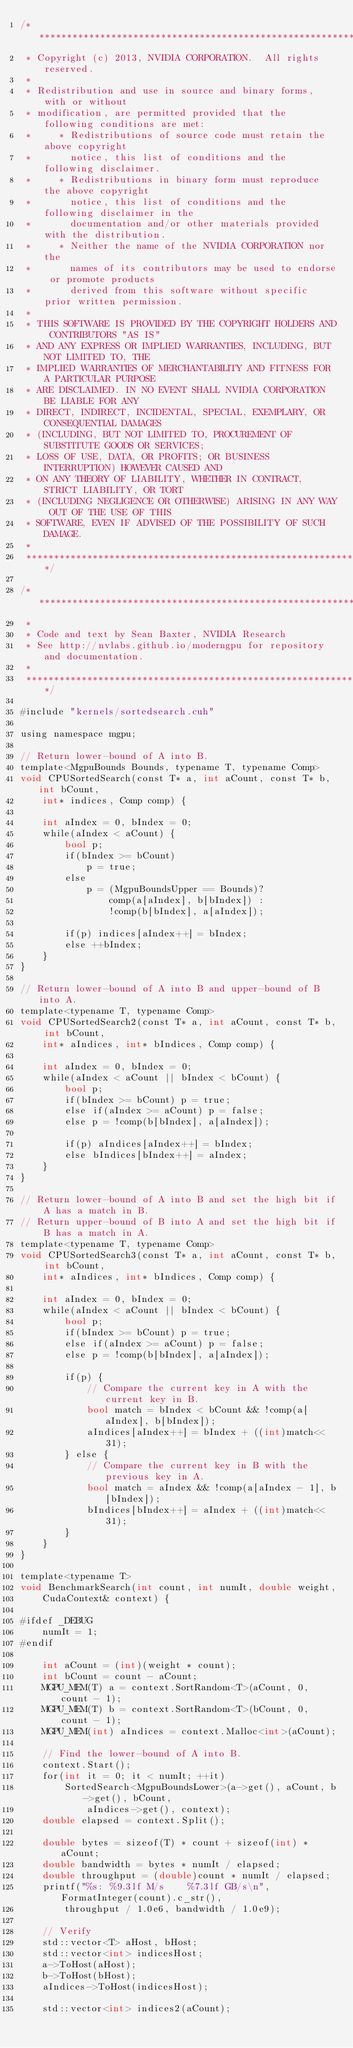<code> <loc_0><loc_0><loc_500><loc_500><_Cuda_>/******************************************************************************
 * Copyright (c) 2013, NVIDIA CORPORATION.  All rights reserved.
 * 
 * Redistribution and use in source and binary forms, with or without
 * modification, are permitted provided that the following conditions are met:
 *     * Redistributions of source code must retain the above copyright
 *       notice, this list of conditions and the following disclaimer.
 *     * Redistributions in binary form must reproduce the above copyright
 *       notice, this list of conditions and the following disclaimer in the
 *       documentation and/or other materials provided with the distribution.
 *     * Neither the name of the NVIDIA CORPORATION nor the
 *       names of its contributors may be used to endorse or promote products
 *       derived from this software without specific prior written permission.
 * 
 * THIS SOFTWARE IS PROVIDED BY THE COPYRIGHT HOLDERS AND CONTRIBUTORS "AS IS" 
 * AND ANY EXPRESS OR IMPLIED WARRANTIES, INCLUDING, BUT NOT LIMITED TO, THE
 * IMPLIED WARRANTIES OF MERCHANTABILITY AND FITNESS FOR A PARTICULAR PURPOSE 
 * ARE DISCLAIMED. IN NO EVENT SHALL NVIDIA CORPORATION BE LIABLE FOR ANY
 * DIRECT, INDIRECT, INCIDENTAL, SPECIAL, EXEMPLARY, OR CONSEQUENTIAL DAMAGES
 * (INCLUDING, BUT NOT LIMITED TO, PROCUREMENT OF SUBSTITUTE GOODS OR SERVICES;
 * LOSS OF USE, DATA, OR PROFITS; OR BUSINESS INTERRUPTION) HOWEVER CAUSED AND
 * ON ANY THEORY OF LIABILITY, WHETHER IN CONTRACT, STRICT LIABILITY, OR TORT
 * (INCLUDING NEGLIGENCE OR OTHERWISE) ARISING IN ANY WAY OUT OF THE USE OF THIS
 * SOFTWARE, EVEN IF ADVISED OF THE POSSIBILITY OF SUCH DAMAGE.
 *
 ******************************************************************************/

/******************************************************************************
 *
 * Code and text by Sean Baxter, NVIDIA Research
 * See http://nvlabs.github.io/moderngpu for repository and documentation.
 *
 ******************************************************************************/

#include "kernels/sortedsearch.cuh"

using namespace mgpu;

// Return lower-bound of A into B.
template<MgpuBounds Bounds, typename T, typename Comp>
void CPUSortedSearch(const T* a, int aCount, const T* b, int bCount, 
	int* indices, Comp comp) {
		
	int aIndex = 0, bIndex = 0;
	while(aIndex < aCount) {
		bool p;
		if(bIndex >= bCount)
			p = true;
		else 
			p = (MgpuBoundsUpper == Bounds)?
				comp(a[aIndex], b[bIndex]) :
				!comp(b[bIndex], a[aIndex]);

		if(p) indices[aIndex++] = bIndex;
		else ++bIndex;
	}
}

// Return lower-bound of A into B and upper-bound of B into A.
template<typename T, typename Comp>
void CPUSortedSearch2(const T* a, int aCount, const T* b, int bCount, 
	int* aIndices, int* bIndices, Comp comp) {

	int aIndex = 0, bIndex = 0;
	while(aIndex < aCount || bIndex < bCount) {
		bool p;
		if(bIndex >= bCount) p = true;
		else if(aIndex >= aCount) p = false;
		else p = !comp(b[bIndex], a[aIndex]);

		if(p) aIndices[aIndex++] = bIndex;
		else bIndices[bIndex++] = aIndex;
	}
}

// Return lower-bound of A into B and set the high bit if A has a match in B.
// Return upper-bound of B into A and set the high bit if B has a match in A.
template<typename T, typename Comp>
void CPUSortedSearch3(const T* a, int aCount, const T* b, int bCount,
	int* aIndices, int* bIndices, Comp comp) {

	int aIndex = 0, bIndex = 0;
	while(aIndex < aCount || bIndex < bCount) {
		bool p;
		if(bIndex >= bCount) p = true;
		else if(aIndex >= aCount) p = false;
		else p = !comp(b[bIndex], a[aIndex]);

		if(p) {
			// Compare the current key in A with the current key in B.
			bool match = bIndex < bCount && !comp(a[aIndex], b[bIndex]);
			aIndices[aIndex++] = bIndex + ((int)match<< 31);
		} else {
			// Compare the current key in B with the previous key in A.
			bool match = aIndex && !comp(a[aIndex - 1], b[bIndex]);
			bIndices[bIndex++] = aIndex + ((int)match<< 31);
		}
	}
}

template<typename T>
void BenchmarkSearch(int count, int numIt, double weight, 
	CudaContext& context) {

#ifdef _DEBUG
	numIt = 1;
#endif

	int aCount = (int)(weight * count);
	int bCount = count - aCount;
	MGPU_MEM(T) a = context.SortRandom<T>(aCount, 0, count - 1);
	MGPU_MEM(T) b = context.SortRandom<T>(bCount, 0, count - 1);
	MGPU_MEM(int) aIndices = context.Malloc<int>(aCount);

	// Find the lower-bound of A into B.
	context.Start();
	for(int it = 0; it < numIt; ++it) 
		SortedSearch<MgpuBoundsLower>(a->get(), aCount, b->get(), bCount,
			aIndices->get(), context);
	double elapsed = context.Split();

	double bytes = sizeof(T) * count + sizeof(int) * aCount;
	double bandwidth = bytes * numIt / elapsed;
	double throughput = (double)count * numIt / elapsed;
	printf("%s: %9.3lf M/s    %7.3lf GB/s\n", FormatInteger(count).c_str(),
		throughput / 1.0e6, bandwidth / 1.0e9);

	// Verify
	std::vector<T> aHost, bHost;
	std::vector<int> indicesHost;
	a->ToHost(aHost);
	b->ToHost(bHost);
	aIndices->ToHost(indicesHost);

	std::vector<int> indices2(aCount);</code> 